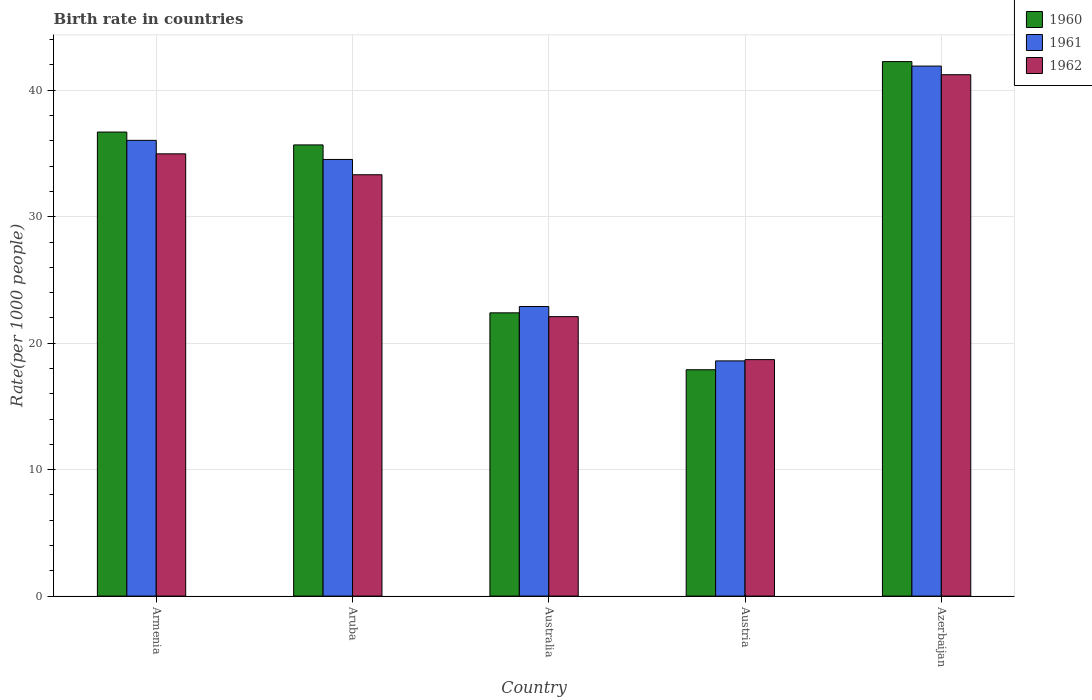How many groups of bars are there?
Offer a very short reply. 5. Are the number of bars per tick equal to the number of legend labels?
Your answer should be compact. Yes. Are the number of bars on each tick of the X-axis equal?
Keep it short and to the point. Yes. How many bars are there on the 4th tick from the left?
Make the answer very short. 3. What is the label of the 2nd group of bars from the left?
Your response must be concise. Aruba. In how many cases, is the number of bars for a given country not equal to the number of legend labels?
Provide a succinct answer. 0. What is the birth rate in 1960 in Austria?
Ensure brevity in your answer.  17.9. Across all countries, what is the maximum birth rate in 1960?
Offer a terse response. 42.27. Across all countries, what is the minimum birth rate in 1962?
Your response must be concise. 18.7. In which country was the birth rate in 1961 maximum?
Your answer should be very brief. Azerbaijan. In which country was the birth rate in 1961 minimum?
Provide a succinct answer. Austria. What is the total birth rate in 1961 in the graph?
Provide a short and direct response. 153.98. What is the difference between the birth rate in 1960 in Australia and that in Azerbaijan?
Make the answer very short. -19.87. What is the difference between the birth rate in 1962 in Armenia and the birth rate in 1960 in Australia?
Ensure brevity in your answer.  12.57. What is the average birth rate in 1960 per country?
Your response must be concise. 30.99. What is the difference between the birth rate of/in 1962 and birth rate of/in 1960 in Austria?
Give a very brief answer. 0.8. In how many countries, is the birth rate in 1962 greater than 2?
Your answer should be very brief. 5. What is the ratio of the birth rate in 1961 in Aruba to that in Azerbaijan?
Make the answer very short. 0.82. Is the birth rate in 1960 in Armenia less than that in Aruba?
Make the answer very short. No. What is the difference between the highest and the second highest birth rate in 1962?
Offer a very short reply. 6.26. What is the difference between the highest and the lowest birth rate in 1961?
Keep it short and to the point. 23.31. In how many countries, is the birth rate in 1962 greater than the average birth rate in 1962 taken over all countries?
Make the answer very short. 3. Is the sum of the birth rate in 1962 in Austria and Azerbaijan greater than the maximum birth rate in 1961 across all countries?
Offer a very short reply. Yes. What does the 3rd bar from the left in Austria represents?
Provide a short and direct response. 1962. Is it the case that in every country, the sum of the birth rate in 1961 and birth rate in 1960 is greater than the birth rate in 1962?
Offer a terse response. Yes. How many bars are there?
Provide a succinct answer. 15. How many countries are there in the graph?
Provide a succinct answer. 5. What is the difference between two consecutive major ticks on the Y-axis?
Your response must be concise. 10. Are the values on the major ticks of Y-axis written in scientific E-notation?
Keep it short and to the point. No. Does the graph contain any zero values?
Offer a very short reply. No. Where does the legend appear in the graph?
Offer a very short reply. Top right. How many legend labels are there?
Your answer should be compact. 3. What is the title of the graph?
Keep it short and to the point. Birth rate in countries. What is the label or title of the Y-axis?
Keep it short and to the point. Rate(per 1000 people). What is the Rate(per 1000 people) in 1960 in Armenia?
Provide a short and direct response. 36.7. What is the Rate(per 1000 people) in 1961 in Armenia?
Provide a short and direct response. 36.04. What is the Rate(per 1000 people) in 1962 in Armenia?
Provide a short and direct response. 34.97. What is the Rate(per 1000 people) of 1960 in Aruba?
Provide a short and direct response. 35.68. What is the Rate(per 1000 people) in 1961 in Aruba?
Offer a terse response. 34.53. What is the Rate(per 1000 people) in 1962 in Aruba?
Give a very brief answer. 33.32. What is the Rate(per 1000 people) of 1960 in Australia?
Keep it short and to the point. 22.4. What is the Rate(per 1000 people) in 1961 in Australia?
Your response must be concise. 22.9. What is the Rate(per 1000 people) of 1962 in Australia?
Keep it short and to the point. 22.1. What is the Rate(per 1000 people) of 1960 in Austria?
Offer a very short reply. 17.9. What is the Rate(per 1000 people) of 1962 in Austria?
Make the answer very short. 18.7. What is the Rate(per 1000 people) in 1960 in Azerbaijan?
Provide a short and direct response. 42.27. What is the Rate(per 1000 people) in 1961 in Azerbaijan?
Keep it short and to the point. 41.91. What is the Rate(per 1000 people) in 1962 in Azerbaijan?
Your response must be concise. 41.23. Across all countries, what is the maximum Rate(per 1000 people) in 1960?
Offer a terse response. 42.27. Across all countries, what is the maximum Rate(per 1000 people) in 1961?
Give a very brief answer. 41.91. Across all countries, what is the maximum Rate(per 1000 people) of 1962?
Your response must be concise. 41.23. Across all countries, what is the minimum Rate(per 1000 people) of 1960?
Your answer should be very brief. 17.9. Across all countries, what is the minimum Rate(per 1000 people) of 1961?
Your answer should be very brief. 18.6. Across all countries, what is the minimum Rate(per 1000 people) of 1962?
Your answer should be compact. 18.7. What is the total Rate(per 1000 people) of 1960 in the graph?
Offer a terse response. 154.94. What is the total Rate(per 1000 people) of 1961 in the graph?
Your answer should be compact. 153.98. What is the total Rate(per 1000 people) in 1962 in the graph?
Your answer should be compact. 150.32. What is the difference between the Rate(per 1000 people) of 1960 in Armenia and that in Aruba?
Your answer should be compact. 1.02. What is the difference between the Rate(per 1000 people) of 1961 in Armenia and that in Aruba?
Offer a terse response. 1.51. What is the difference between the Rate(per 1000 people) in 1962 in Armenia and that in Aruba?
Give a very brief answer. 1.65. What is the difference between the Rate(per 1000 people) of 1960 in Armenia and that in Australia?
Give a very brief answer. 14.3. What is the difference between the Rate(per 1000 people) in 1961 in Armenia and that in Australia?
Offer a terse response. 13.14. What is the difference between the Rate(per 1000 people) of 1962 in Armenia and that in Australia?
Provide a short and direct response. 12.87. What is the difference between the Rate(per 1000 people) in 1960 in Armenia and that in Austria?
Offer a very short reply. 18.8. What is the difference between the Rate(per 1000 people) of 1961 in Armenia and that in Austria?
Provide a short and direct response. 17.44. What is the difference between the Rate(per 1000 people) in 1962 in Armenia and that in Austria?
Provide a short and direct response. 16.27. What is the difference between the Rate(per 1000 people) in 1960 in Armenia and that in Azerbaijan?
Make the answer very short. -5.57. What is the difference between the Rate(per 1000 people) of 1961 in Armenia and that in Azerbaijan?
Your answer should be very brief. -5.87. What is the difference between the Rate(per 1000 people) in 1962 in Armenia and that in Azerbaijan?
Provide a short and direct response. -6.26. What is the difference between the Rate(per 1000 people) of 1960 in Aruba and that in Australia?
Your answer should be compact. 13.28. What is the difference between the Rate(per 1000 people) of 1961 in Aruba and that in Australia?
Make the answer very short. 11.63. What is the difference between the Rate(per 1000 people) in 1962 in Aruba and that in Australia?
Provide a short and direct response. 11.22. What is the difference between the Rate(per 1000 people) of 1960 in Aruba and that in Austria?
Offer a terse response. 17.78. What is the difference between the Rate(per 1000 people) in 1961 in Aruba and that in Austria?
Make the answer very short. 15.93. What is the difference between the Rate(per 1000 people) in 1962 in Aruba and that in Austria?
Give a very brief answer. 14.62. What is the difference between the Rate(per 1000 people) of 1960 in Aruba and that in Azerbaijan?
Your answer should be compact. -6.59. What is the difference between the Rate(per 1000 people) in 1961 in Aruba and that in Azerbaijan?
Offer a terse response. -7.38. What is the difference between the Rate(per 1000 people) of 1962 in Aruba and that in Azerbaijan?
Offer a terse response. -7.91. What is the difference between the Rate(per 1000 people) of 1960 in Australia and that in Austria?
Your response must be concise. 4.5. What is the difference between the Rate(per 1000 people) in 1962 in Australia and that in Austria?
Ensure brevity in your answer.  3.4. What is the difference between the Rate(per 1000 people) of 1960 in Australia and that in Azerbaijan?
Make the answer very short. -19.87. What is the difference between the Rate(per 1000 people) in 1961 in Australia and that in Azerbaijan?
Ensure brevity in your answer.  -19.01. What is the difference between the Rate(per 1000 people) in 1962 in Australia and that in Azerbaijan?
Provide a succinct answer. -19.13. What is the difference between the Rate(per 1000 people) in 1960 in Austria and that in Azerbaijan?
Give a very brief answer. -24.37. What is the difference between the Rate(per 1000 people) of 1961 in Austria and that in Azerbaijan?
Keep it short and to the point. -23.31. What is the difference between the Rate(per 1000 people) in 1962 in Austria and that in Azerbaijan?
Your answer should be compact. -22.53. What is the difference between the Rate(per 1000 people) of 1960 in Armenia and the Rate(per 1000 people) of 1961 in Aruba?
Ensure brevity in your answer.  2.17. What is the difference between the Rate(per 1000 people) of 1960 in Armenia and the Rate(per 1000 people) of 1962 in Aruba?
Offer a very short reply. 3.38. What is the difference between the Rate(per 1000 people) of 1961 in Armenia and the Rate(per 1000 people) of 1962 in Aruba?
Ensure brevity in your answer.  2.72. What is the difference between the Rate(per 1000 people) in 1960 in Armenia and the Rate(per 1000 people) in 1961 in Australia?
Keep it short and to the point. 13.8. What is the difference between the Rate(per 1000 people) of 1960 in Armenia and the Rate(per 1000 people) of 1962 in Australia?
Give a very brief answer. 14.6. What is the difference between the Rate(per 1000 people) in 1961 in Armenia and the Rate(per 1000 people) in 1962 in Australia?
Offer a very short reply. 13.94. What is the difference between the Rate(per 1000 people) in 1960 in Armenia and the Rate(per 1000 people) in 1961 in Austria?
Provide a succinct answer. 18.1. What is the difference between the Rate(per 1000 people) of 1960 in Armenia and the Rate(per 1000 people) of 1962 in Austria?
Keep it short and to the point. 18. What is the difference between the Rate(per 1000 people) of 1961 in Armenia and the Rate(per 1000 people) of 1962 in Austria?
Your answer should be compact. 17.34. What is the difference between the Rate(per 1000 people) of 1960 in Armenia and the Rate(per 1000 people) of 1961 in Azerbaijan?
Your answer should be very brief. -5.22. What is the difference between the Rate(per 1000 people) in 1960 in Armenia and the Rate(per 1000 people) in 1962 in Azerbaijan?
Offer a terse response. -4.53. What is the difference between the Rate(per 1000 people) of 1961 in Armenia and the Rate(per 1000 people) of 1962 in Azerbaijan?
Provide a short and direct response. -5.19. What is the difference between the Rate(per 1000 people) in 1960 in Aruba and the Rate(per 1000 people) in 1961 in Australia?
Your answer should be very brief. 12.78. What is the difference between the Rate(per 1000 people) of 1960 in Aruba and the Rate(per 1000 people) of 1962 in Australia?
Your answer should be compact. 13.58. What is the difference between the Rate(per 1000 people) of 1961 in Aruba and the Rate(per 1000 people) of 1962 in Australia?
Your answer should be very brief. 12.43. What is the difference between the Rate(per 1000 people) of 1960 in Aruba and the Rate(per 1000 people) of 1961 in Austria?
Keep it short and to the point. 17.08. What is the difference between the Rate(per 1000 people) of 1960 in Aruba and the Rate(per 1000 people) of 1962 in Austria?
Give a very brief answer. 16.98. What is the difference between the Rate(per 1000 people) in 1961 in Aruba and the Rate(per 1000 people) in 1962 in Austria?
Provide a succinct answer. 15.83. What is the difference between the Rate(per 1000 people) in 1960 in Aruba and the Rate(per 1000 people) in 1961 in Azerbaijan?
Your answer should be very brief. -6.23. What is the difference between the Rate(per 1000 people) of 1960 in Aruba and the Rate(per 1000 people) of 1962 in Azerbaijan?
Make the answer very short. -5.55. What is the difference between the Rate(per 1000 people) in 1961 in Aruba and the Rate(per 1000 people) in 1962 in Azerbaijan?
Your answer should be compact. -6.7. What is the difference between the Rate(per 1000 people) of 1960 in Australia and the Rate(per 1000 people) of 1962 in Austria?
Offer a terse response. 3.7. What is the difference between the Rate(per 1000 people) of 1961 in Australia and the Rate(per 1000 people) of 1962 in Austria?
Your response must be concise. 4.2. What is the difference between the Rate(per 1000 people) in 1960 in Australia and the Rate(per 1000 people) in 1961 in Azerbaijan?
Your response must be concise. -19.51. What is the difference between the Rate(per 1000 people) of 1960 in Australia and the Rate(per 1000 people) of 1962 in Azerbaijan?
Ensure brevity in your answer.  -18.83. What is the difference between the Rate(per 1000 people) in 1961 in Australia and the Rate(per 1000 people) in 1962 in Azerbaijan?
Ensure brevity in your answer.  -18.33. What is the difference between the Rate(per 1000 people) in 1960 in Austria and the Rate(per 1000 people) in 1961 in Azerbaijan?
Keep it short and to the point. -24.01. What is the difference between the Rate(per 1000 people) in 1960 in Austria and the Rate(per 1000 people) in 1962 in Azerbaijan?
Give a very brief answer. -23.33. What is the difference between the Rate(per 1000 people) in 1961 in Austria and the Rate(per 1000 people) in 1962 in Azerbaijan?
Offer a terse response. -22.63. What is the average Rate(per 1000 people) in 1960 per country?
Make the answer very short. 30.99. What is the average Rate(per 1000 people) of 1961 per country?
Offer a very short reply. 30.8. What is the average Rate(per 1000 people) of 1962 per country?
Keep it short and to the point. 30.06. What is the difference between the Rate(per 1000 people) in 1960 and Rate(per 1000 people) in 1961 in Armenia?
Your answer should be compact. 0.66. What is the difference between the Rate(per 1000 people) of 1960 and Rate(per 1000 people) of 1962 in Armenia?
Your answer should be compact. 1.72. What is the difference between the Rate(per 1000 people) of 1961 and Rate(per 1000 people) of 1962 in Armenia?
Your answer should be very brief. 1.07. What is the difference between the Rate(per 1000 people) in 1960 and Rate(per 1000 people) in 1961 in Aruba?
Make the answer very short. 1.15. What is the difference between the Rate(per 1000 people) of 1960 and Rate(per 1000 people) of 1962 in Aruba?
Provide a succinct answer. 2.36. What is the difference between the Rate(per 1000 people) of 1961 and Rate(per 1000 people) of 1962 in Aruba?
Provide a short and direct response. 1.21. What is the difference between the Rate(per 1000 people) in 1960 and Rate(per 1000 people) in 1961 in Australia?
Keep it short and to the point. -0.5. What is the difference between the Rate(per 1000 people) in 1960 and Rate(per 1000 people) in 1961 in Austria?
Your response must be concise. -0.7. What is the difference between the Rate(per 1000 people) of 1960 and Rate(per 1000 people) of 1961 in Azerbaijan?
Your answer should be very brief. 0.35. What is the difference between the Rate(per 1000 people) in 1960 and Rate(per 1000 people) in 1962 in Azerbaijan?
Your response must be concise. 1.04. What is the difference between the Rate(per 1000 people) of 1961 and Rate(per 1000 people) of 1962 in Azerbaijan?
Your response must be concise. 0.68. What is the ratio of the Rate(per 1000 people) in 1960 in Armenia to that in Aruba?
Offer a terse response. 1.03. What is the ratio of the Rate(per 1000 people) of 1961 in Armenia to that in Aruba?
Keep it short and to the point. 1.04. What is the ratio of the Rate(per 1000 people) of 1962 in Armenia to that in Aruba?
Keep it short and to the point. 1.05. What is the ratio of the Rate(per 1000 people) in 1960 in Armenia to that in Australia?
Your answer should be compact. 1.64. What is the ratio of the Rate(per 1000 people) of 1961 in Armenia to that in Australia?
Offer a very short reply. 1.57. What is the ratio of the Rate(per 1000 people) of 1962 in Armenia to that in Australia?
Your response must be concise. 1.58. What is the ratio of the Rate(per 1000 people) in 1960 in Armenia to that in Austria?
Make the answer very short. 2.05. What is the ratio of the Rate(per 1000 people) of 1961 in Armenia to that in Austria?
Offer a terse response. 1.94. What is the ratio of the Rate(per 1000 people) in 1962 in Armenia to that in Austria?
Offer a very short reply. 1.87. What is the ratio of the Rate(per 1000 people) in 1960 in Armenia to that in Azerbaijan?
Give a very brief answer. 0.87. What is the ratio of the Rate(per 1000 people) in 1961 in Armenia to that in Azerbaijan?
Offer a terse response. 0.86. What is the ratio of the Rate(per 1000 people) in 1962 in Armenia to that in Azerbaijan?
Your answer should be compact. 0.85. What is the ratio of the Rate(per 1000 people) of 1960 in Aruba to that in Australia?
Your answer should be compact. 1.59. What is the ratio of the Rate(per 1000 people) of 1961 in Aruba to that in Australia?
Offer a terse response. 1.51. What is the ratio of the Rate(per 1000 people) in 1962 in Aruba to that in Australia?
Ensure brevity in your answer.  1.51. What is the ratio of the Rate(per 1000 people) in 1960 in Aruba to that in Austria?
Give a very brief answer. 1.99. What is the ratio of the Rate(per 1000 people) in 1961 in Aruba to that in Austria?
Your answer should be very brief. 1.86. What is the ratio of the Rate(per 1000 people) of 1962 in Aruba to that in Austria?
Offer a terse response. 1.78. What is the ratio of the Rate(per 1000 people) of 1960 in Aruba to that in Azerbaijan?
Offer a terse response. 0.84. What is the ratio of the Rate(per 1000 people) of 1961 in Aruba to that in Azerbaijan?
Provide a short and direct response. 0.82. What is the ratio of the Rate(per 1000 people) of 1962 in Aruba to that in Azerbaijan?
Offer a very short reply. 0.81. What is the ratio of the Rate(per 1000 people) of 1960 in Australia to that in Austria?
Your response must be concise. 1.25. What is the ratio of the Rate(per 1000 people) in 1961 in Australia to that in Austria?
Make the answer very short. 1.23. What is the ratio of the Rate(per 1000 people) of 1962 in Australia to that in Austria?
Your answer should be compact. 1.18. What is the ratio of the Rate(per 1000 people) in 1960 in Australia to that in Azerbaijan?
Provide a short and direct response. 0.53. What is the ratio of the Rate(per 1000 people) in 1961 in Australia to that in Azerbaijan?
Ensure brevity in your answer.  0.55. What is the ratio of the Rate(per 1000 people) in 1962 in Australia to that in Azerbaijan?
Offer a terse response. 0.54. What is the ratio of the Rate(per 1000 people) in 1960 in Austria to that in Azerbaijan?
Keep it short and to the point. 0.42. What is the ratio of the Rate(per 1000 people) of 1961 in Austria to that in Azerbaijan?
Provide a succinct answer. 0.44. What is the ratio of the Rate(per 1000 people) of 1962 in Austria to that in Azerbaijan?
Ensure brevity in your answer.  0.45. What is the difference between the highest and the second highest Rate(per 1000 people) in 1960?
Offer a terse response. 5.57. What is the difference between the highest and the second highest Rate(per 1000 people) in 1961?
Keep it short and to the point. 5.87. What is the difference between the highest and the second highest Rate(per 1000 people) in 1962?
Your answer should be very brief. 6.26. What is the difference between the highest and the lowest Rate(per 1000 people) in 1960?
Your answer should be very brief. 24.37. What is the difference between the highest and the lowest Rate(per 1000 people) in 1961?
Provide a succinct answer. 23.31. What is the difference between the highest and the lowest Rate(per 1000 people) in 1962?
Offer a terse response. 22.53. 